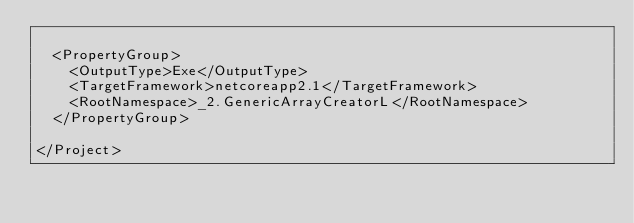Convert code to text. <code><loc_0><loc_0><loc_500><loc_500><_XML_>
  <PropertyGroup>
    <OutputType>Exe</OutputType>
    <TargetFramework>netcoreapp2.1</TargetFramework>
    <RootNamespace>_2.GenericArrayCreatorL</RootNamespace>
  </PropertyGroup>

</Project>
</code> 